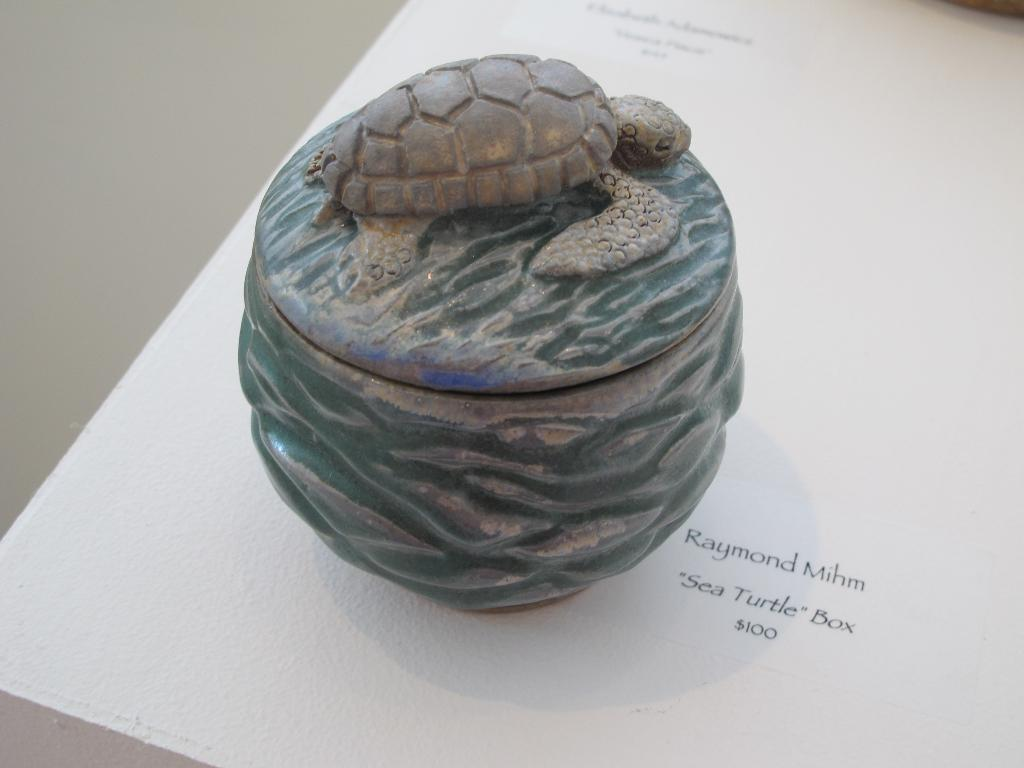What is the main object in the center of the image? There is a paperweight in the center of the image. What is depicted on the paperweight? The paperweight has a tortoise on it. What else can be seen in the image besides the paperweight? There is a paper in the image. Where is the paper located? The paper is on a table. How does the paperweight contribute to the game of volleyball in the image? There is no game of volleyball present in the image, and the paperweight does not contribute to any such activity. 